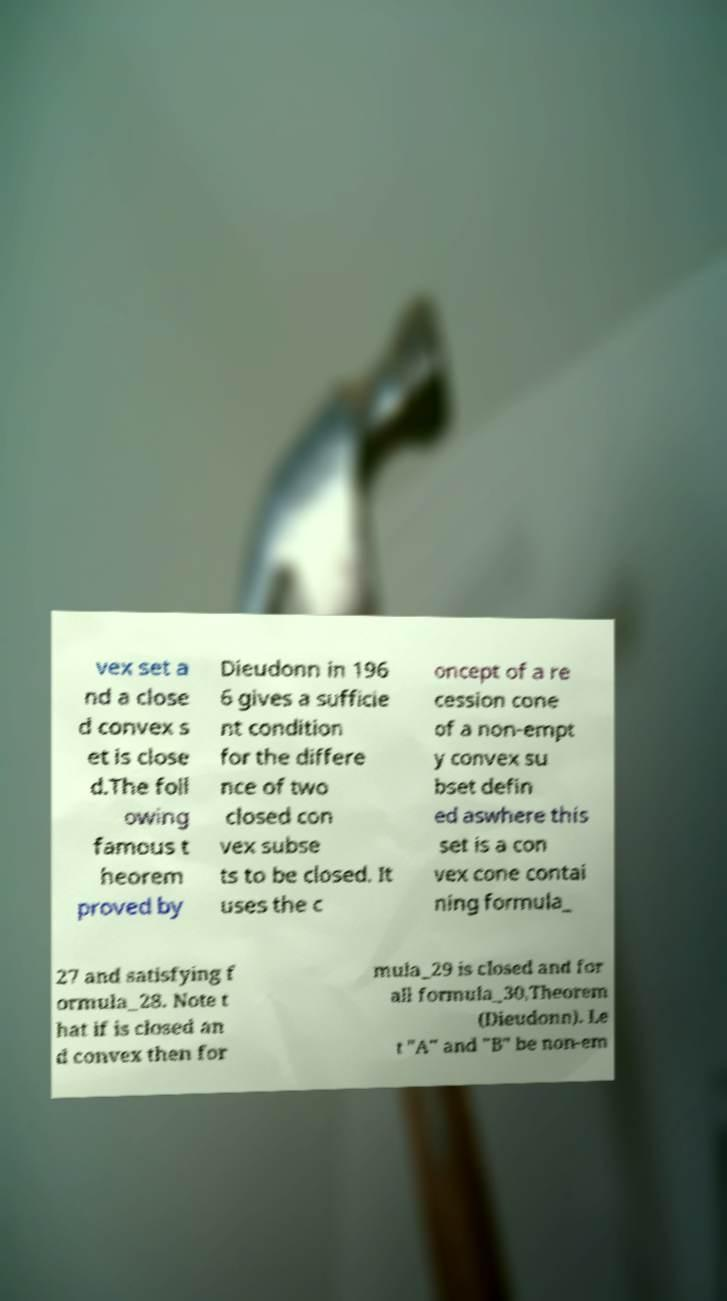Please identify and transcribe the text found in this image. vex set a nd a close d convex s et is close d.The foll owing famous t heorem proved by Dieudonn in 196 6 gives a sufficie nt condition for the differe nce of two closed con vex subse ts to be closed. It uses the c oncept of a re cession cone of a non-empt y convex su bset defin ed aswhere this set is a con vex cone contai ning formula_ 27 and satisfying f ormula_28. Note t hat if is closed an d convex then for mula_29 is closed and for all formula_30,Theorem (Dieudonn). Le t "A" and "B" be non-em 